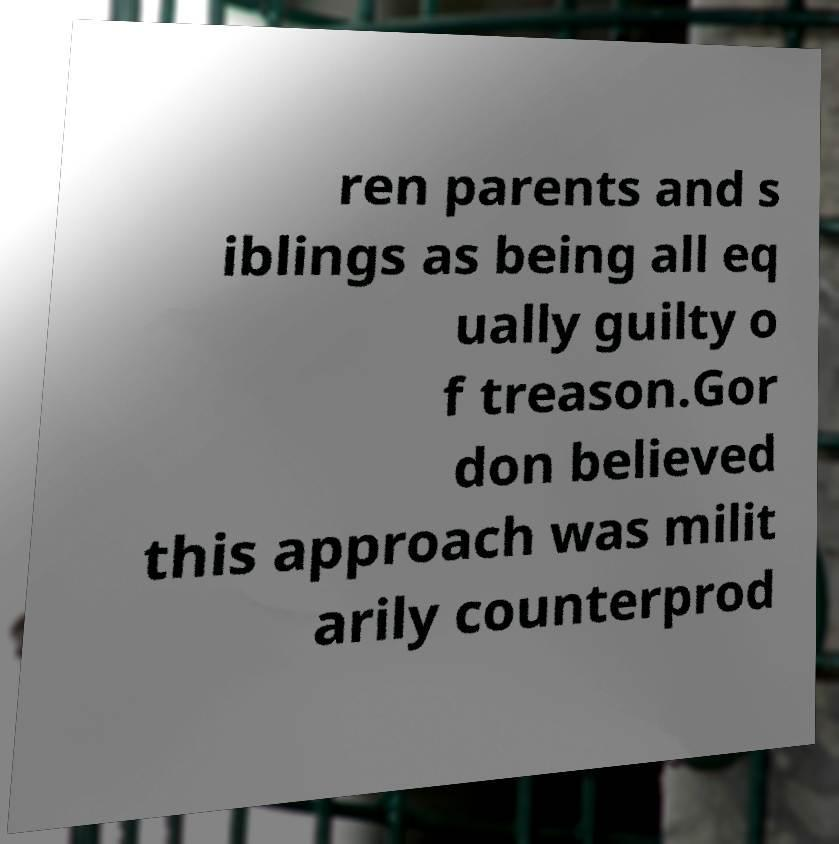Could you assist in decoding the text presented in this image and type it out clearly? ren parents and s iblings as being all eq ually guilty o f treason.Gor don believed this approach was milit arily counterprod 